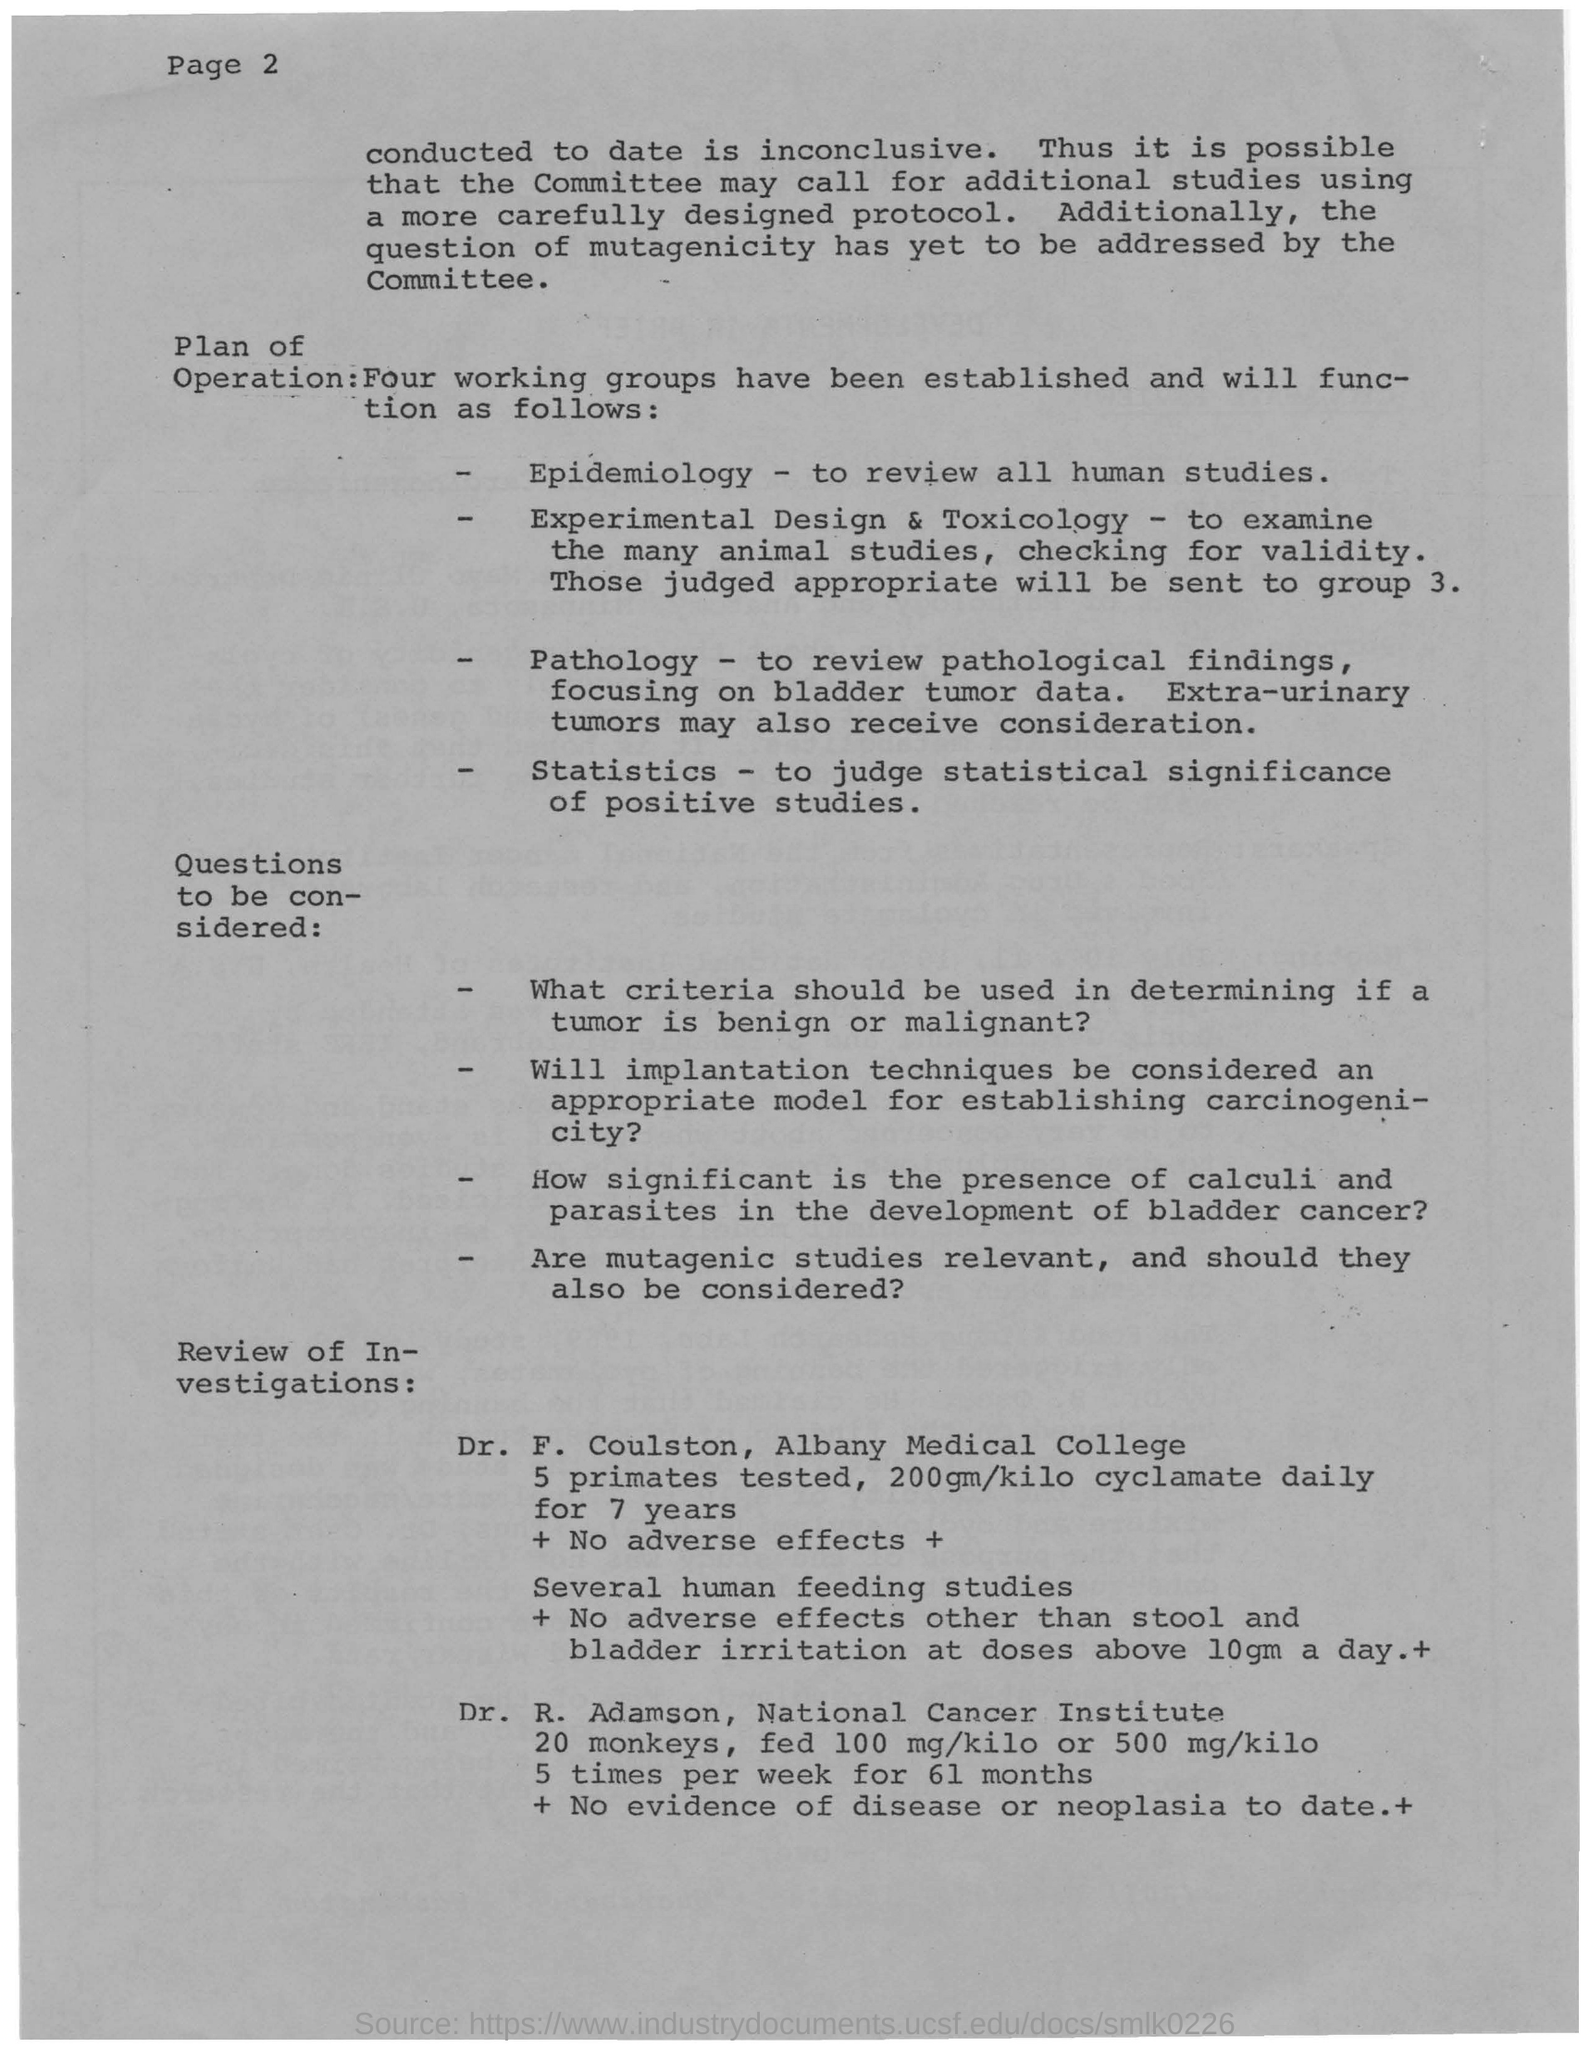Draw attention to some important aspects in this diagram. The primates were given a daily dosage of 200 grams of cyclamate per kilogram of body weight for a period of 7 years, which equates to approximately 0.02% of their body weight in cyclamate per day. Dr. F. Coulston tested five primates in total. The operation of epidemiology involves reviewing all human studies in order to understand the patterns, causes, and effects of diseases and health conditions in populations. 